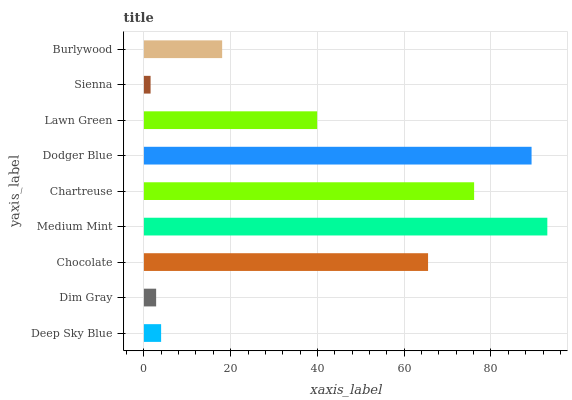Is Sienna the minimum?
Answer yes or no. Yes. Is Medium Mint the maximum?
Answer yes or no. Yes. Is Dim Gray the minimum?
Answer yes or no. No. Is Dim Gray the maximum?
Answer yes or no. No. Is Deep Sky Blue greater than Dim Gray?
Answer yes or no. Yes. Is Dim Gray less than Deep Sky Blue?
Answer yes or no. Yes. Is Dim Gray greater than Deep Sky Blue?
Answer yes or no. No. Is Deep Sky Blue less than Dim Gray?
Answer yes or no. No. Is Lawn Green the high median?
Answer yes or no. Yes. Is Lawn Green the low median?
Answer yes or no. Yes. Is Dodger Blue the high median?
Answer yes or no. No. Is Deep Sky Blue the low median?
Answer yes or no. No. 